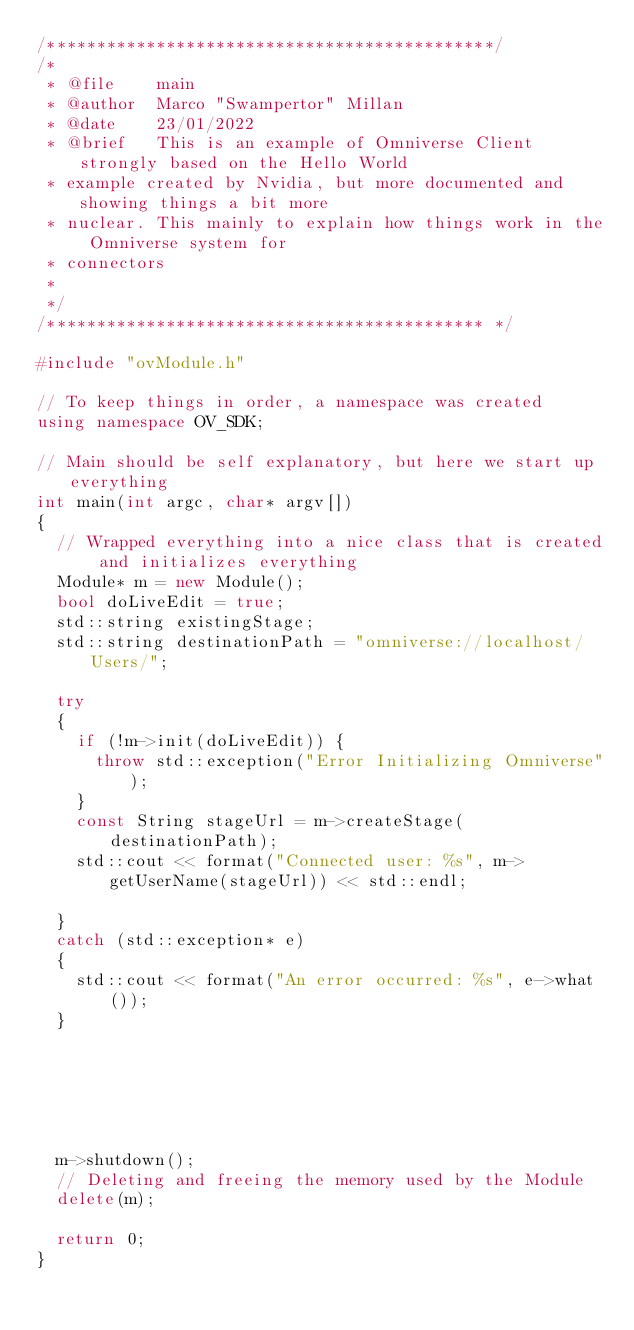<code> <loc_0><loc_0><loc_500><loc_500><_C++_>/*********************************************/
/*
 * @file 	main
 * @author	Marco "Swampertor" Millan
 * @date	23/01/2022
 * @brief	This is an example of Omniverse Client strongly based on the Hello World
 * example created by Nvidia, but more documented and showing things a bit more
 * nuclear. This mainly to explain how things work in the Omniverse system for
 * connectors
 *
 */
/******************************************** */

#include "ovModule.h"

// To keep things in order, a namespace was created
using namespace OV_SDK;

// Main should be self explanatory, but here we start up everything
int main(int argc, char* argv[])
{
  // Wrapped everything into a nice class that is created and initializes everything
  Module* m = new Module();
  bool doLiveEdit = true;
  std::string existingStage;
  std::string destinationPath = "omniverse://localhost/Users/";

  try
  {
    if (!m->init(doLiveEdit)) {
      throw std::exception("Error Initializing Omniverse");
    }
    const String stageUrl = m->createStage(destinationPath);
    std::cout << format("Connected user: %s", m->getUserName(stageUrl)) << std::endl;

  }
  catch (std::exception* e)
  {
    std::cout << format("An error occurred: %s", e->what());
  }
  





  m->shutdown();
  // Deleting and freeing the memory used by the Module
  delete(m);

  return 0;
}</code> 